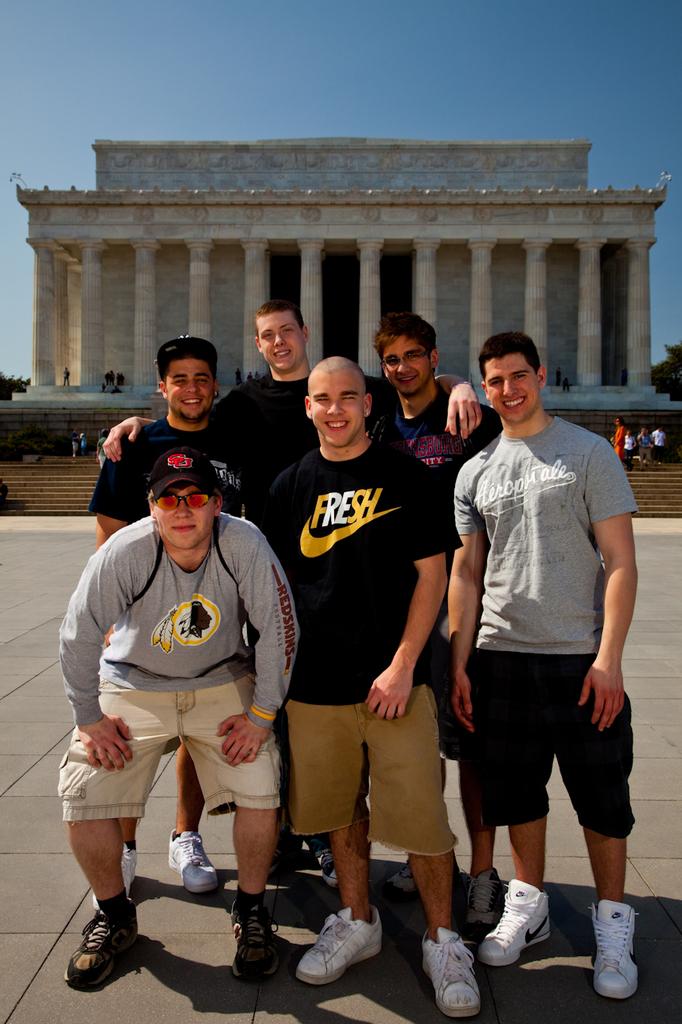What word is written in black and yellow on the nike shirt of the man in the center?
Provide a succinct answer. Fresh. 